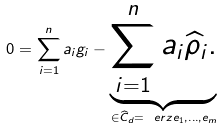Convert formula to latex. <formula><loc_0><loc_0><loc_500><loc_500>0 = \sum _ { i = 1 } ^ { n } a _ { i } g _ { i } - \underbrace { \sum _ { i = 1 } ^ { n } a _ { i } \widehat { \rho } _ { i } . } _ { \in \widehat { C } _ { d } = \ e r z { e _ { 1 } , \dots , e _ { m } } }</formula> 